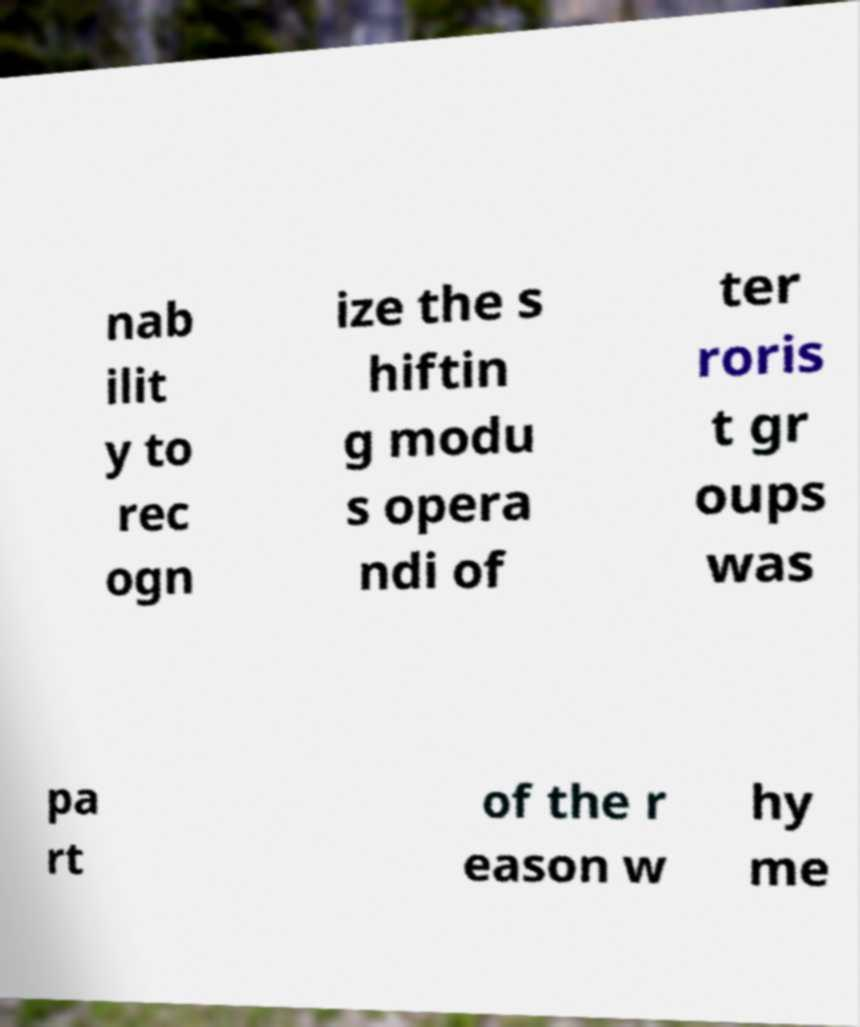Please read and relay the text visible in this image. What does it say? nab ilit y to rec ogn ize the s hiftin g modu s opera ndi of ter roris t gr oups was pa rt of the r eason w hy me 